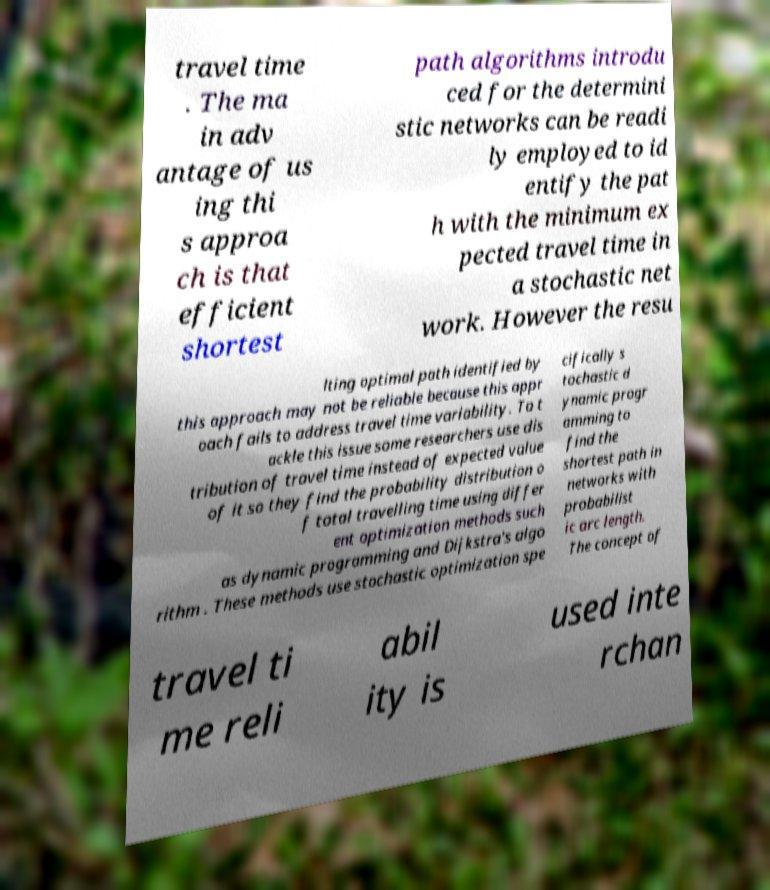Could you assist in decoding the text presented in this image and type it out clearly? travel time . The ma in adv antage of us ing thi s approa ch is that efficient shortest path algorithms introdu ced for the determini stic networks can be readi ly employed to id entify the pat h with the minimum ex pected travel time in a stochastic net work. However the resu lting optimal path identified by this approach may not be reliable because this appr oach fails to address travel time variability. To t ackle this issue some researchers use dis tribution of travel time instead of expected value of it so they find the probability distribution o f total travelling time using differ ent optimization methods such as dynamic programming and Dijkstra's algo rithm . These methods use stochastic optimization spe cifically s tochastic d ynamic progr amming to find the shortest path in networks with probabilist ic arc length. The concept of travel ti me reli abil ity is used inte rchan 